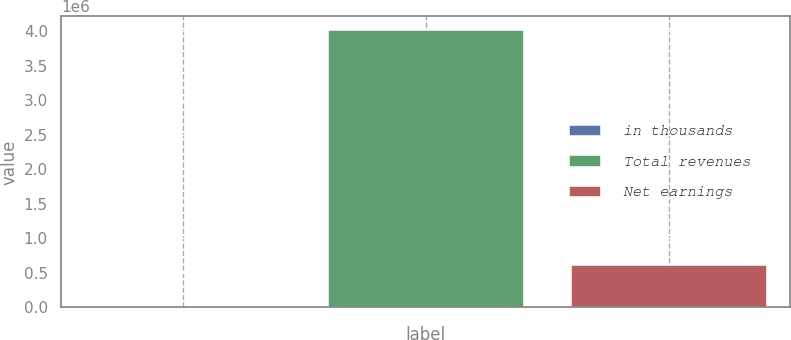Convert chart. <chart><loc_0><loc_0><loc_500><loc_500><bar_chart><fcel>in thousands<fcel>Total revenues<fcel>Net earnings<nl><fcel>2017<fcel>4.01589e+06<fcel>610494<nl></chart> 